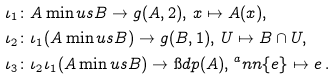Convert formula to latex. <formula><loc_0><loc_0><loc_500><loc_500>\iota _ { 1 } & \colon A \min u s B \to g ( A , 2 ) , \, x \mapsto A ( x ) , \\ \iota _ { 2 } & \colon \iota _ { 1 } ( A \min u s B ) \to g ( B , 1 ) , \, U \mapsto B \cap U , \\ \iota _ { 3 } & \colon \iota _ { 2 } \iota _ { 1 } ( A \min u s B ) \to \i d p ( A ) , \, ^ { a } n n \{ e \} \mapsto e \, .</formula> 